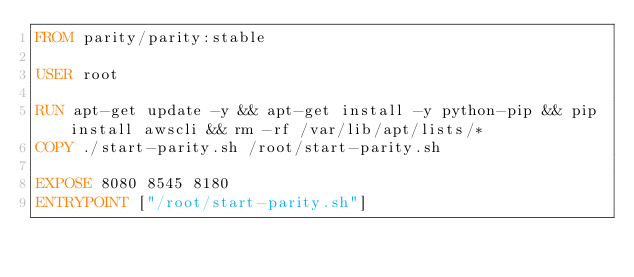<code> <loc_0><loc_0><loc_500><loc_500><_Dockerfile_>FROM parity/parity:stable

USER root

RUN apt-get update -y && apt-get install -y python-pip && pip install awscli && rm -rf /var/lib/apt/lists/* 
COPY ./start-parity.sh /root/start-parity.sh

EXPOSE 8080 8545 8180
ENTRYPOINT ["/root/start-parity.sh"]
</code> 